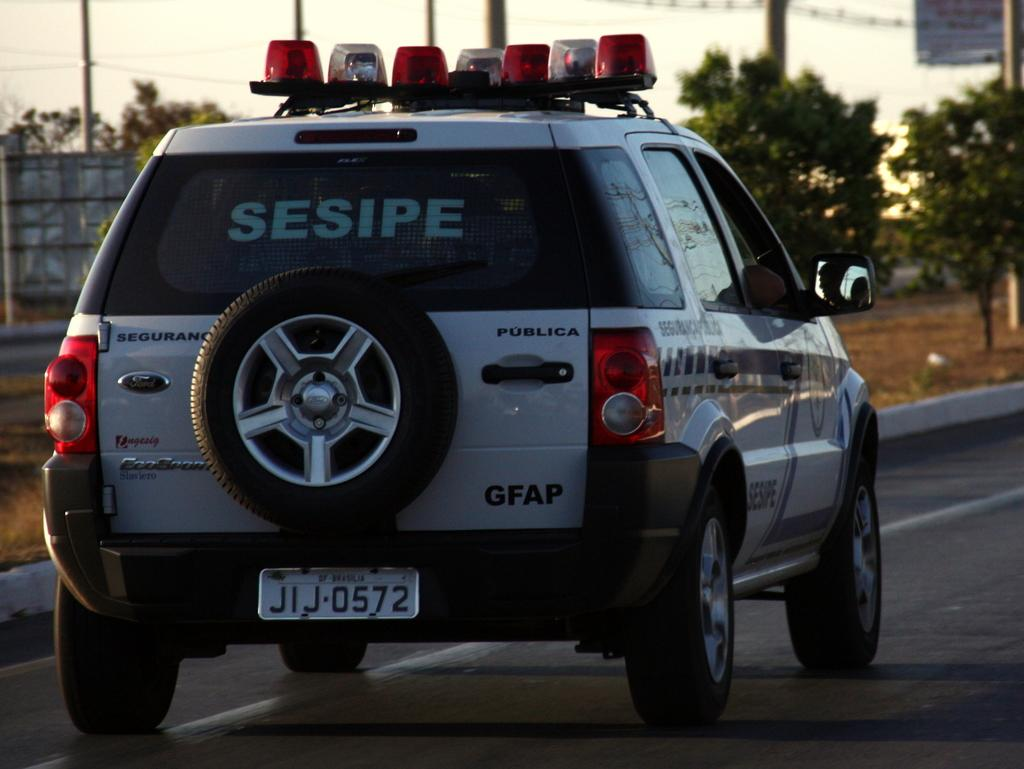What is the main subject of the image? The main subject of the image is a car on the road. What can be seen in the background of the image? In the background of the image, there is grass, a board, a hoarding, poles, trees, and the sky. How many elements can be identified in the background of the image? There are six elements in the background of the image: grass, a board, a hoarding, poles, trees, and the sky. What type of farm animals can be seen grazing in the background of the image? There are no farm animals present in the image; it features a car on the road and various elements in the background, but no farm animals. What attraction is visible in the background of the image? There is no attraction visible in the background of the image; it features a car on the road and various elements in the background, but no specific attractions. 